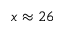Convert formula to latex. <formula><loc_0><loc_0><loc_500><loc_500>x \approx 2 6</formula> 